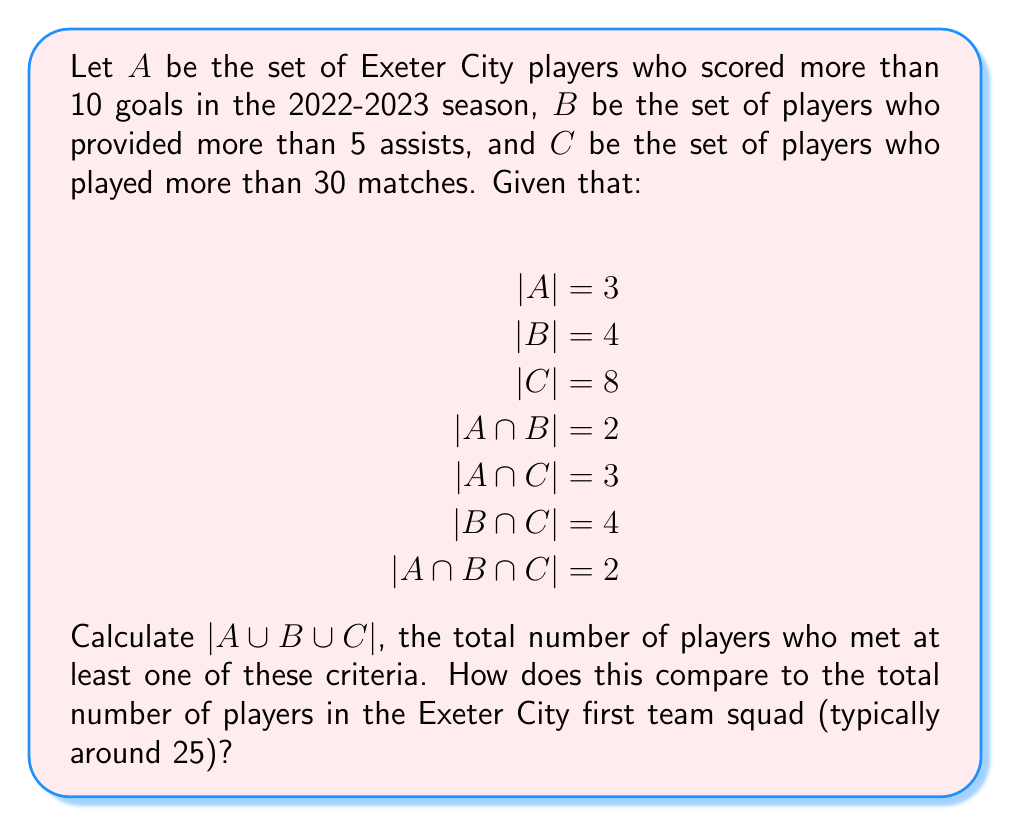Can you answer this question? To solve this problem, we'll use the Inclusion-Exclusion Principle for three sets:

$$|A \cup B \cup C| = |A| + |B| + |C| - |A \cap B| - |A \cap C| - |B \cap C| + |A \cap B \cap C|$$

Let's substitute the given values:

$$|A \cup B \cup C| = 3 + 4 + 8 - 2 - 3 - 4 + 2$$

Now, let's calculate:

$$|A \cup B \cup C| = 15 - 9 + 2 = 8$$

Therefore, 8 players met at least one of the criteria.

To compare this to the typical squad size:
8 players out of approximately 25 in the squad met at least one of these high-performance criteria. This represents about 32% of the squad.

This analysis shows that while Exeter City has a core group of high-performing players, there's still room for improvement across the squad. As a critical Exeter City fan, you might consider this a decent foundation but recognize the need for more players to step up their performance to compete at a higher level.
Answer: $|A \cup B \cup C| = 8$ players

This represents approximately 32% of a typical 25-player squad. 